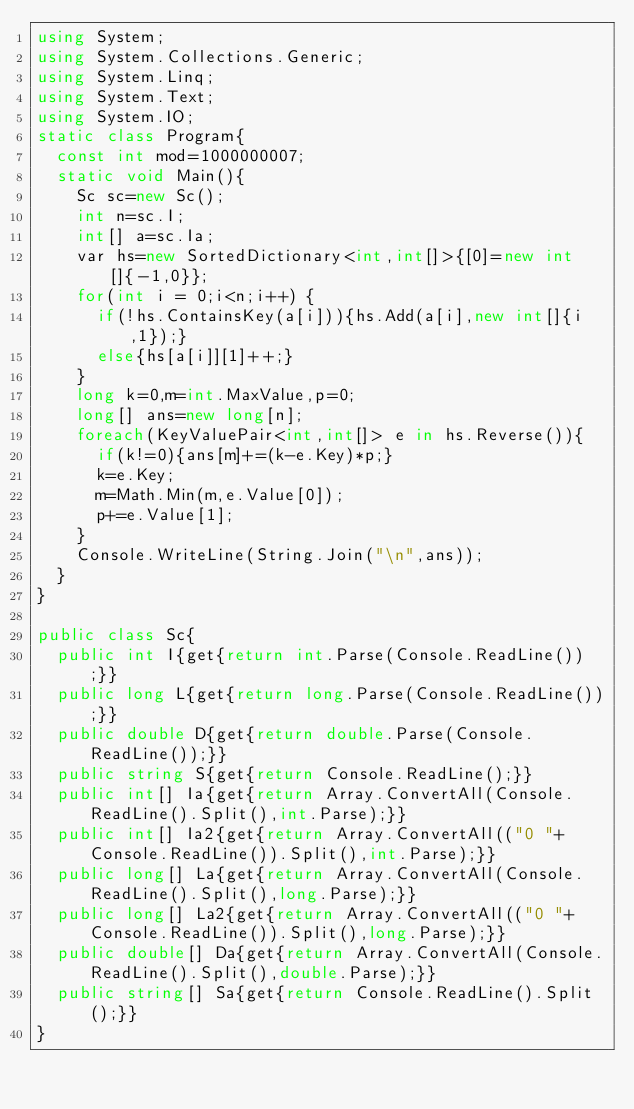Convert code to text. <code><loc_0><loc_0><loc_500><loc_500><_C#_>using System;
using System.Collections.Generic;
using System.Linq;
using System.Text;
using System.IO;
static class Program{
	const int mod=1000000007;
	static void Main(){
		Sc sc=new Sc();
		int n=sc.I;
		int[] a=sc.Ia;
		var hs=new SortedDictionary<int,int[]>{[0]=new int[]{-1,0}};
		for(int i = 0;i<n;i++) {
			if(!hs.ContainsKey(a[i])){hs.Add(a[i],new int[]{i,1});}
			else{hs[a[i]][1]++;}
		}
		long k=0,m=int.MaxValue,p=0;
		long[] ans=new long[n];
		foreach(KeyValuePair<int,int[]> e in hs.Reverse()){
			if(k!=0){ans[m]+=(k-e.Key)*p;}
			k=e.Key;
			m=Math.Min(m,e.Value[0]);
			p+=e.Value[1];
		}
		Console.WriteLine(String.Join("\n",ans));
	}
}

public class Sc{
	public int I{get{return int.Parse(Console.ReadLine());}}
	public long L{get{return long.Parse(Console.ReadLine());}}
	public double D{get{return double.Parse(Console.ReadLine());}}
	public string S{get{return Console.ReadLine();}}
	public int[] Ia{get{return Array.ConvertAll(Console.ReadLine().Split(),int.Parse);}}
	public int[] Ia2{get{return Array.ConvertAll(("0 "+Console.ReadLine()).Split(),int.Parse);}}
	public long[] La{get{return Array.ConvertAll(Console.ReadLine().Split(),long.Parse);}}
	public long[] La2{get{return Array.ConvertAll(("0 "+Console.ReadLine()).Split(),long.Parse);}}
	public double[] Da{get{return Array.ConvertAll(Console.ReadLine().Split(),double.Parse);}}
	public string[] Sa{get{return Console.ReadLine().Split();}}
}
</code> 